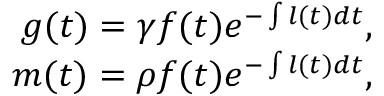Convert formula to latex. <formula><loc_0><loc_0><loc_500><loc_500>\begin{array} { r } { g ( t ) = \gamma f ( t ) e ^ { - \int l ( t ) d t } , } \\ { m ( t ) = \rho f ( t ) e ^ { - \int l ( t ) d t } , } \end{array}</formula> 